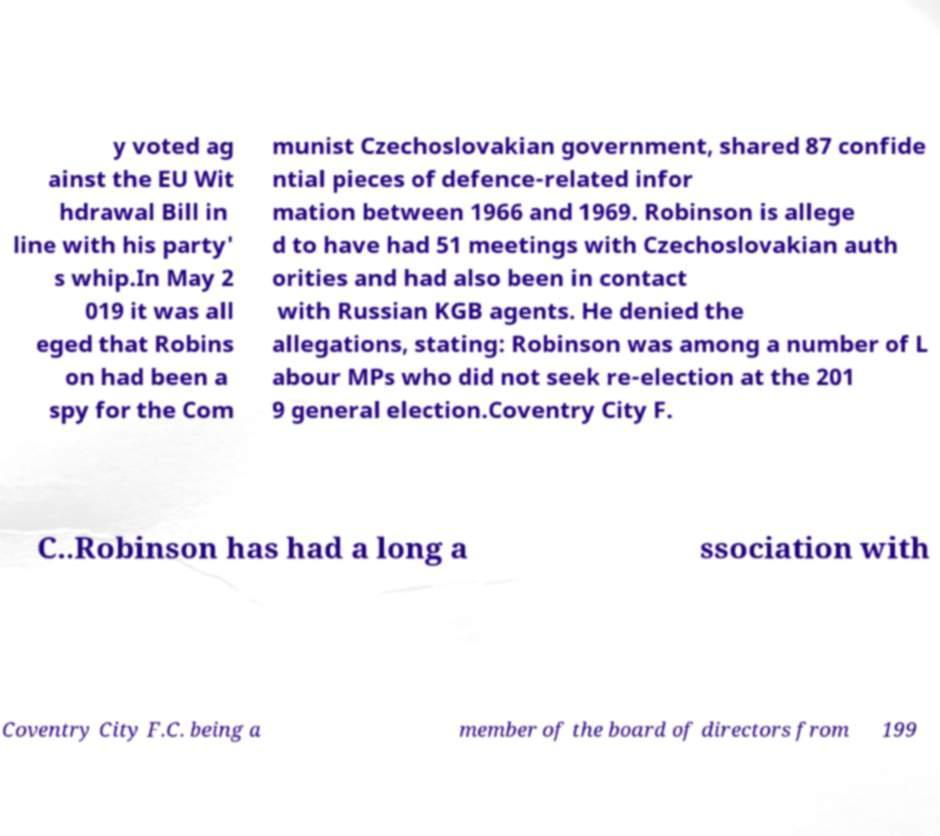Please identify and transcribe the text found in this image. y voted ag ainst the EU Wit hdrawal Bill in line with his party' s whip.In May 2 019 it was all eged that Robins on had been a spy for the Com munist Czechoslovakian government, shared 87 confide ntial pieces of defence-related infor mation between 1966 and 1969. Robinson is allege d to have had 51 meetings with Czechoslovakian auth orities and had also been in contact with Russian KGB agents. He denied the allegations, stating: Robinson was among a number of L abour MPs who did not seek re-election at the 201 9 general election.Coventry City F. C..Robinson has had a long a ssociation with Coventry City F.C. being a member of the board of directors from 199 